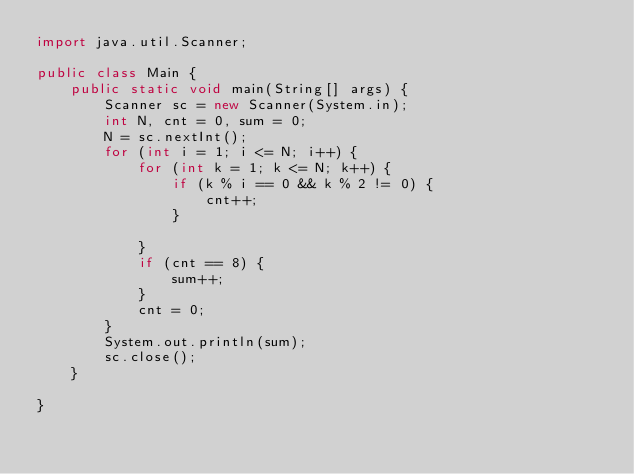Convert code to text. <code><loc_0><loc_0><loc_500><loc_500><_Java_>import java.util.Scanner;

public class Main {
	public static void main(String[] args) {
		Scanner sc = new Scanner(System.in);
		int N, cnt = 0, sum = 0;
		N = sc.nextInt();
		for (int i = 1; i <= N; i++) {
			for (int k = 1; k <= N; k++) {
				if (k % i == 0 && k % 2 != 0) {
					cnt++;
				}

			}
			if (cnt == 8) {
				sum++;
			}
			cnt = 0;
		}
		System.out.println(sum);
		sc.close();
	}

}</code> 